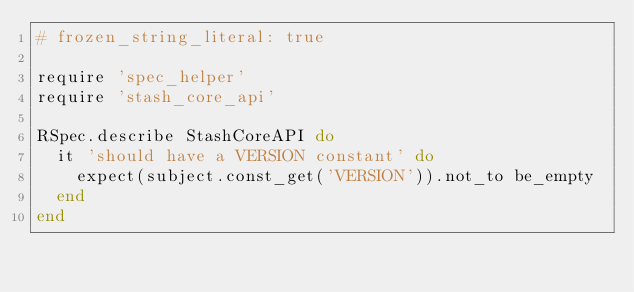<code> <loc_0><loc_0><loc_500><loc_500><_Ruby_># frozen_string_literal: true

require 'spec_helper'
require 'stash_core_api'

RSpec.describe StashCoreAPI do
  it 'should have a VERSION constant' do
    expect(subject.const_get('VERSION')).not_to be_empty
  end
end
</code> 